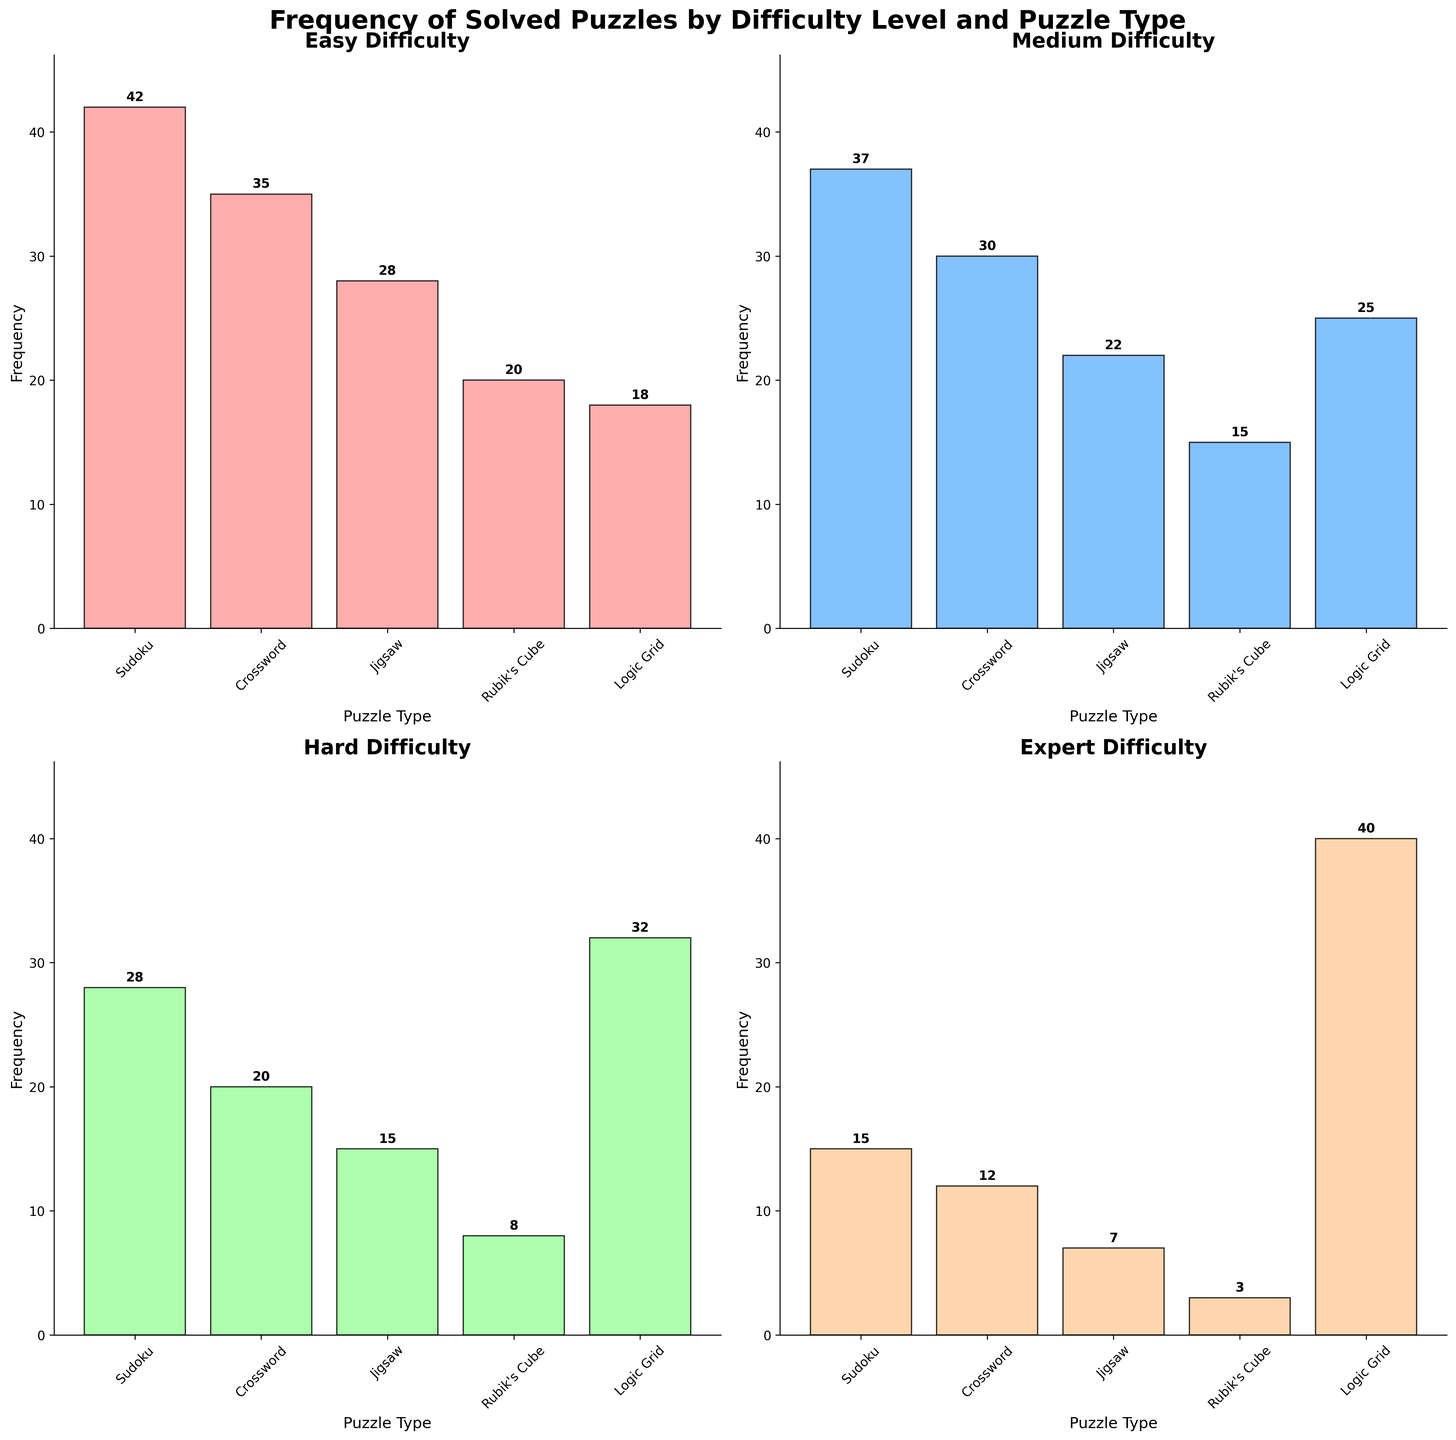Which puzzle type has the highest frequency for the "Easy" difficulty level? Referring to the subplot titled "Easy Difficulty," we see that the bar for "Sudoku" is the tallest. Checking the label above the bar, we find the frequency is 42.
Answer: Sudoku How does the frequency of solved "Medium" Sudoku compare to "Easy" Sudoku? Looking at both subplots for "Medium Difficulty" and "Easy Difficulty," the frequency of "Medium" Sudoku is 37 and "Easy" Sudoku is 42. Therefore, the frequency of "Medium" Sudoku is less.
Answer: Medium Sudoku is less Which puzzle type is most frequently solved in the "Expert" difficulty level? From the "Expert Difficulty" subplot, the tallest bar corresponds to the "Logic Grid" puzzle with a frequency of 40, the highest among the types.
Answer: Logic Grid What is the difference in frequency between "Medium" Crosswords and "Hard" Crosswords? In the subplots for "Medium Difficulty" and "Hard Difficulty," the frequency of "Medium Crosswords" is 30 and "Hard Crosswords" is 20. Subtracting these gives 10.
Answer: 10 Summing up the frequencies of all types of puzzles at the "Hard" difficulty level, what total do we get? Adding the frequencies from the "Hard Difficulty" subplot, we have 28 (Sudoku) + 20 (Crossword) + 15 (Jigsaw) + 8 (Rubik's Cube) + 32 (Logic Grid) = 103.
Answer: 103 How many types of puzzles are shown for each difficulty level in the figure? Observing each subplot, we count the different labels on the x-axis. Each difficulty level (Easy, Medium, Hard, Expert) displays five puzzle types: Sudoku, Crossword, Jigsaw, Rubik's Cube, and Logic Grid.
Answer: 5 Which difficulty level has the least frequency for solved Rubik's Cube puzzles? Comparing frequencies of Rubik's Cube across all subplots, "Expert" difficulty has the smallest bar with a frequency of 3.
Answer: Expert What's the average frequency of the "Logic Grid" puzzle across all difficulty levels? Summing the frequencies from each subplot: 18 (Easy) + 25 (Medium) + 32 (Hard) + 40 (Expert) gives 115. Dividing by 4 difficulty levels, the average is 115 / 4 = 28.75.
Answer: 28.75 Is the frequency of "Medium Jigsaw" puzzles greater than "Hard Jigsaw" puzzles? Referring to the "Medium Difficulty" and "Hard Difficulty" subplots, "Medium Jigsaw" has a frequency of 22, while "Hard Jigsaw" has a frequency of 15. Yes, 22 is greater than 15.
Answer: Yes What is the total frequency of all solved puzzles at the "Expert" difficulty level? From the "Expert Difficulty" subplot, adding all frequencies: 15 (Sudoku) + 12 (Crossword) + 7 (Jigsaw) + 3 (Rubik's Cube) + 40 (Logic Grid) = 77.
Answer: 77 